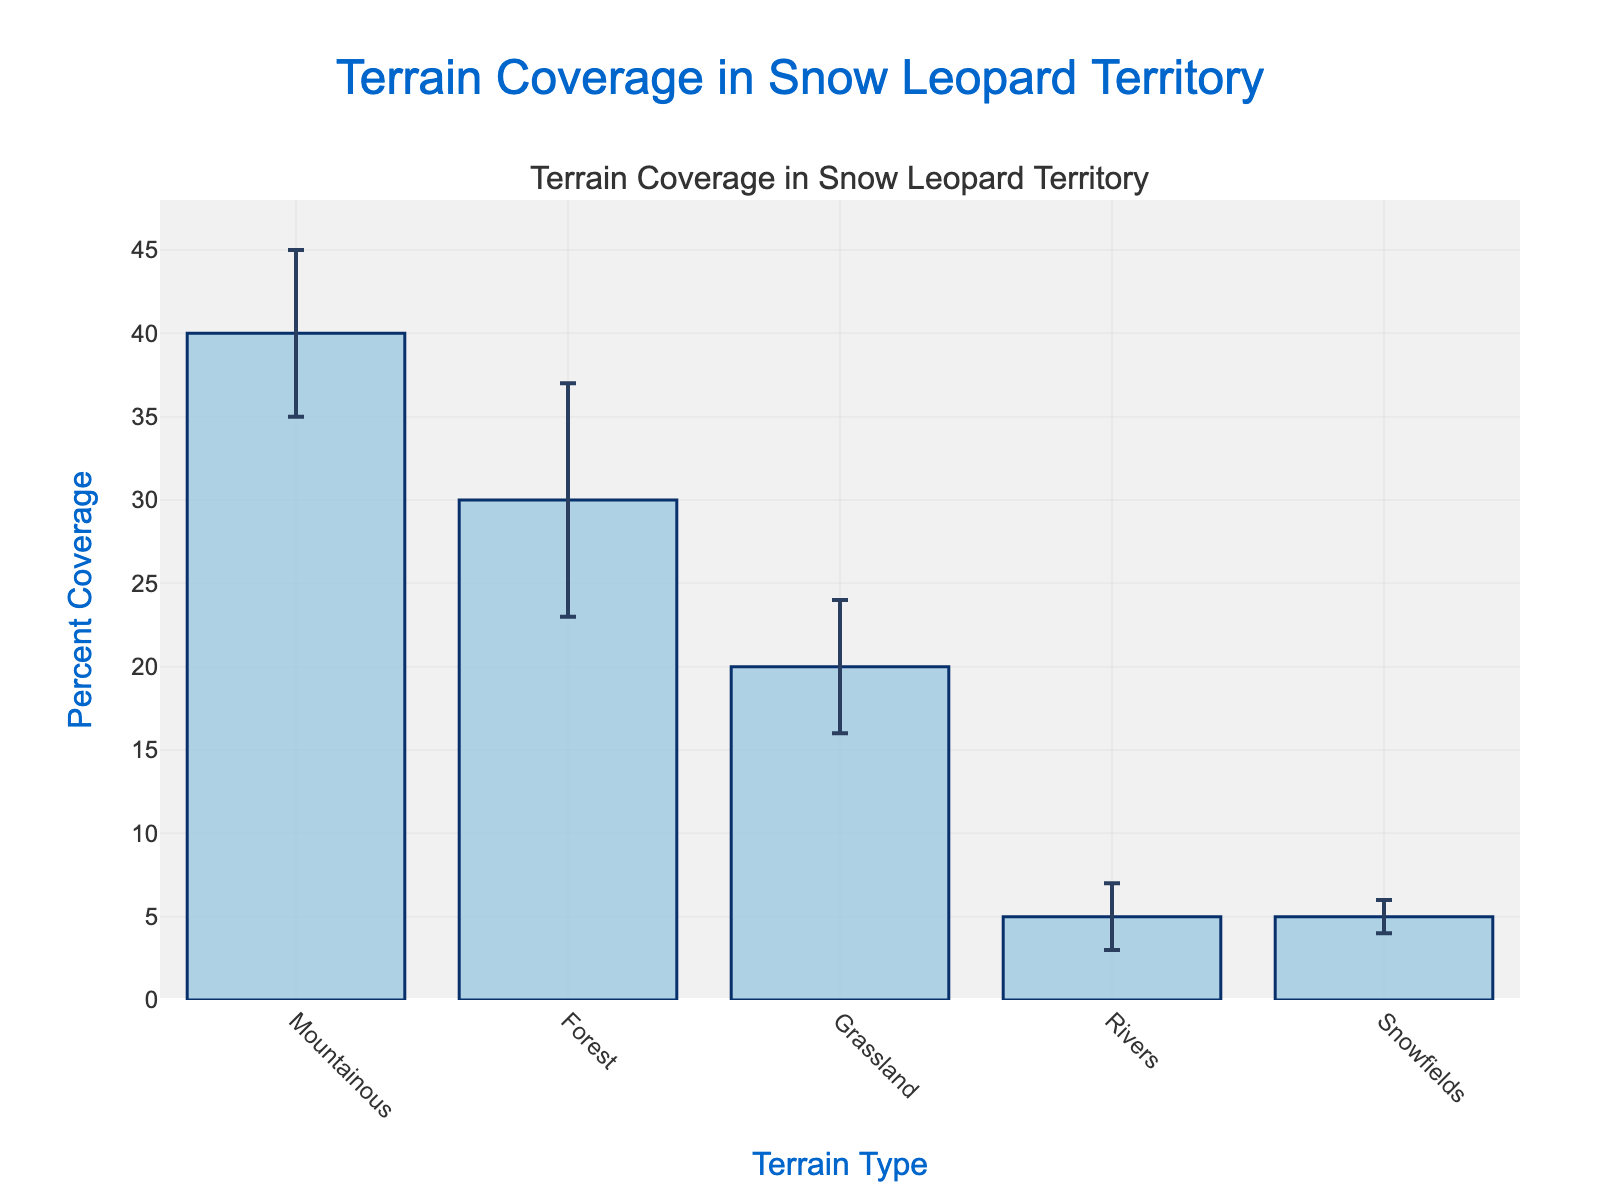What's the title of the figure? The title can be found at the top of the figure, it is prominently displayed in larger text.
Answer: Terrain Coverage in Snow Leopard Territory What is the percent coverage of Grassland? To find the percent coverage of Grassland, locate the Grassland bar on the x-axis and read the corresponding value on the y-axis.
Answer: 20% What terrain type has the lowest percent coverage? Identify the shortest bar in the chart, which represents the lowest percent coverage value.
Answer: Rivers and Snowfields How does the error bar for Forest compare to that for Snowfields? The length of the error bars can be observed directly from each bar. Compare the height of the error bar for Forest with the error bar for Snowfields.
Answer: The error bar for Forest is longer What is the total percent coverage of terrain types excluding Rivers? Sum the percent coverage values of all terrain types except Rivers: Mountainous (40%) + Forest (30%) + Grassland (20%) + Snowfields (5%).
Answer: 95% Which terrain type has the highest standard deviation, and what does this imply about its coverage stability? Standard deviation is represented by the error bars; the length of the error bar indicates the extent of deviation. The longer the error bar, the higher the standard deviation, implying less stability.
Answer: Forest; it implies less stability Compare the percent coverage difference between Mountainous and Grassland. Subtract the percent coverage of Grassland from the percent coverage of Mountainous: 40% - 20%.
Answer: 20% If Rivers and Snowfields are combined into one category, what would be the total percent coverage? Add the percent coverage values of Rivers and Snowfields: 5% + 5%.
Answer: 10% Which terrain type would require more attention if we are focusing on the most stable terrain? The most stable terrain would have the shortest error bar, indicating the least variation in coverage.
Answer: Snowfields What is the average percent coverage of all terrain types? Calculate the average by summing the percent coverages of all terrain types and dividing by the number of terrain types: (40% + 30% + 20% + 5% + 5%) / 5.
Answer: 20% 